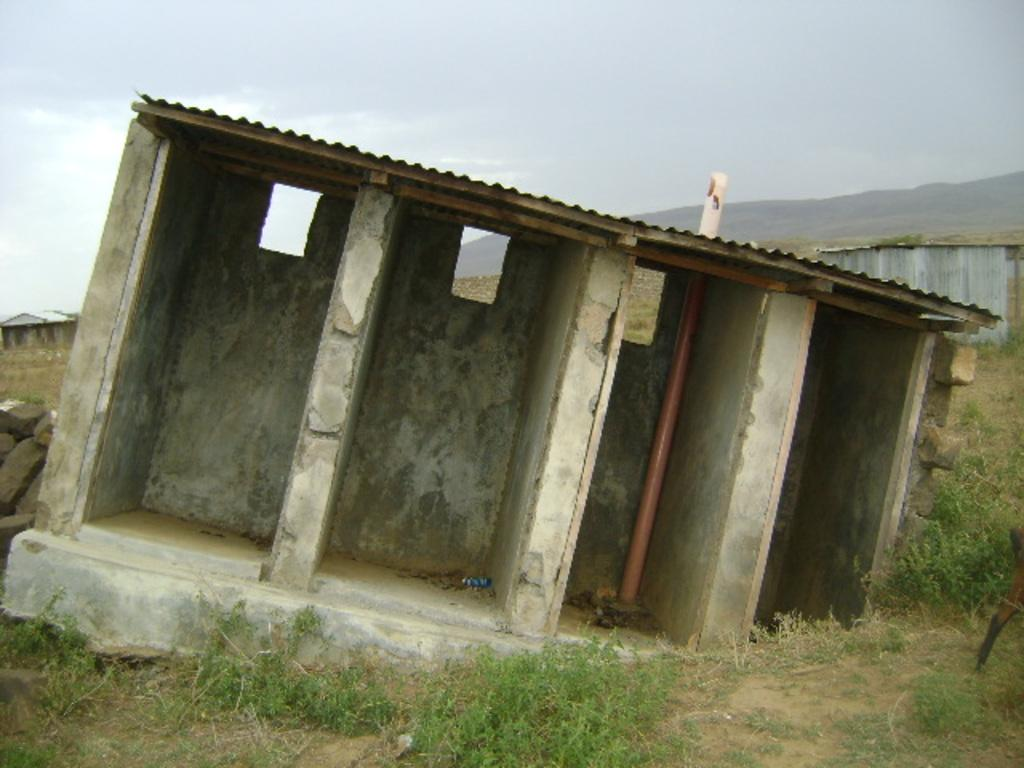What type of structures can be seen in the image? There are sheds in the image. What type of vegetation is visible in the image? There is grass visible in the image, and there are plants on the ground. How would you describe the sky in the image? The sky is blue and cloudy in the image. What type of bread is being served at the feast in the image? There is no feast or bread present in the image; it features sheds, grass, plants, and a blue, cloudy sky. 